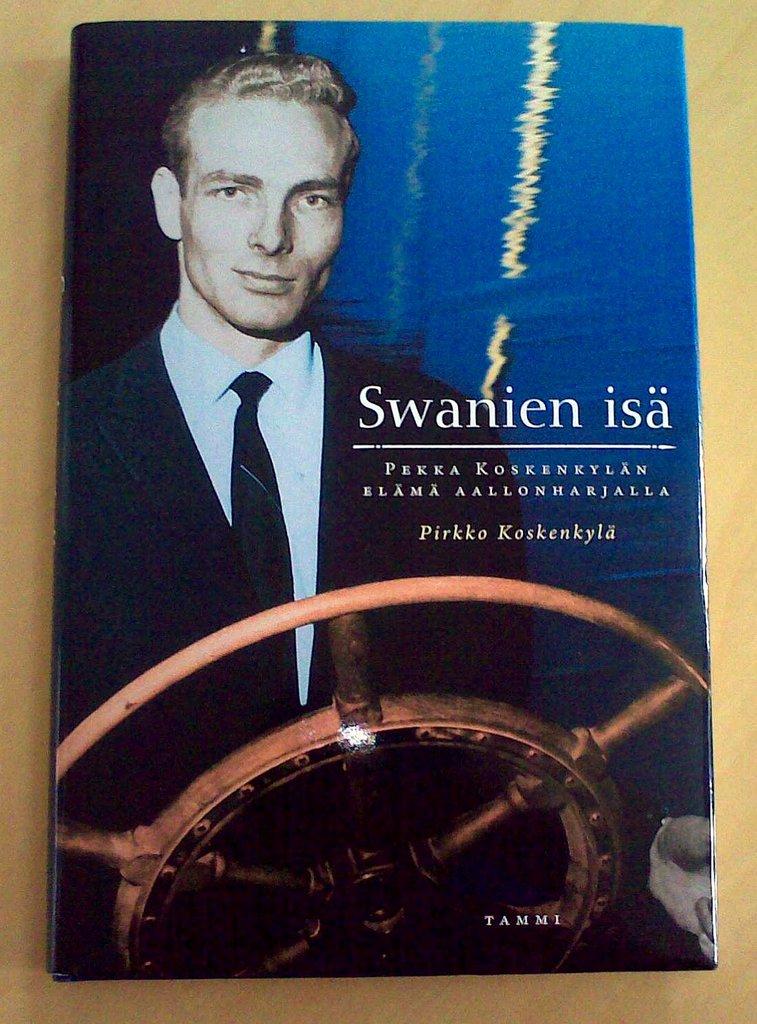Who wrote this book?
Your answer should be very brief. Pirkko koskenkyla. Is this written in english?
Provide a succinct answer. No. 